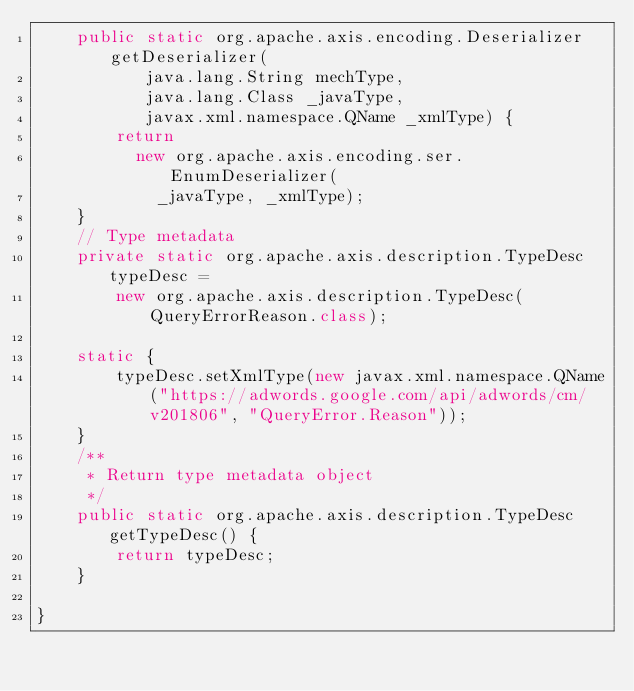Convert code to text. <code><loc_0><loc_0><loc_500><loc_500><_Java_>    public static org.apache.axis.encoding.Deserializer getDeserializer(
           java.lang.String mechType, 
           java.lang.Class _javaType,  
           javax.xml.namespace.QName _xmlType) {
        return 
          new org.apache.axis.encoding.ser.EnumDeserializer(
            _javaType, _xmlType);
    }
    // Type metadata
    private static org.apache.axis.description.TypeDesc typeDesc =
        new org.apache.axis.description.TypeDesc(QueryErrorReason.class);

    static {
        typeDesc.setXmlType(new javax.xml.namespace.QName("https://adwords.google.com/api/adwords/cm/v201806", "QueryError.Reason"));
    }
    /**
     * Return type metadata object
     */
    public static org.apache.axis.description.TypeDesc getTypeDesc() {
        return typeDesc;
    }

}
</code> 